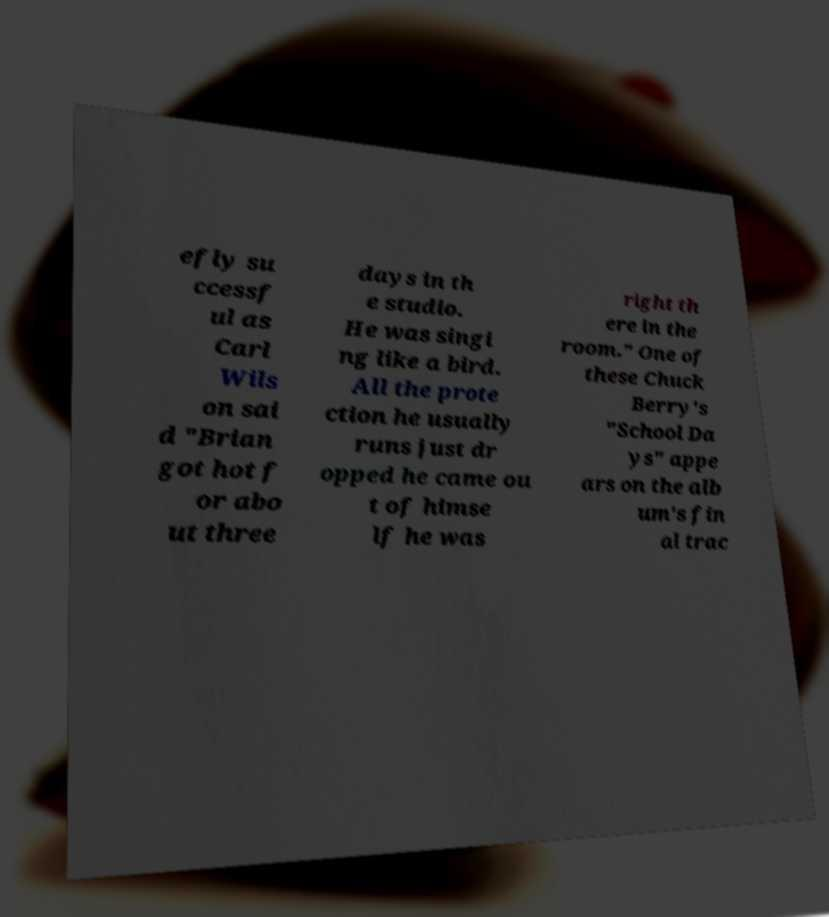Can you read and provide the text displayed in the image?This photo seems to have some interesting text. Can you extract and type it out for me? efly su ccessf ul as Carl Wils on sai d "Brian got hot f or abo ut three days in th e studio. He was singi ng like a bird. All the prote ction he usually runs just dr opped he came ou t of himse lf he was right th ere in the room." One of these Chuck Berry's "School Da ys" appe ars on the alb um's fin al trac 